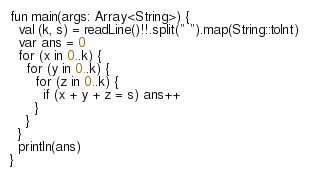Convert code to text. <code><loc_0><loc_0><loc_500><loc_500><_Kotlin_>fun main(args: Array<String>) {
  val (k, s) = readLine()!!.split(" ").map(String::toInt)
  var ans = 0
  for (x in 0..k) {
    for (y in 0..k) {
      for (z in 0..k) {
        if (x + y + z = s) ans++
      }
    }
  }
  println(ans)
}</code> 